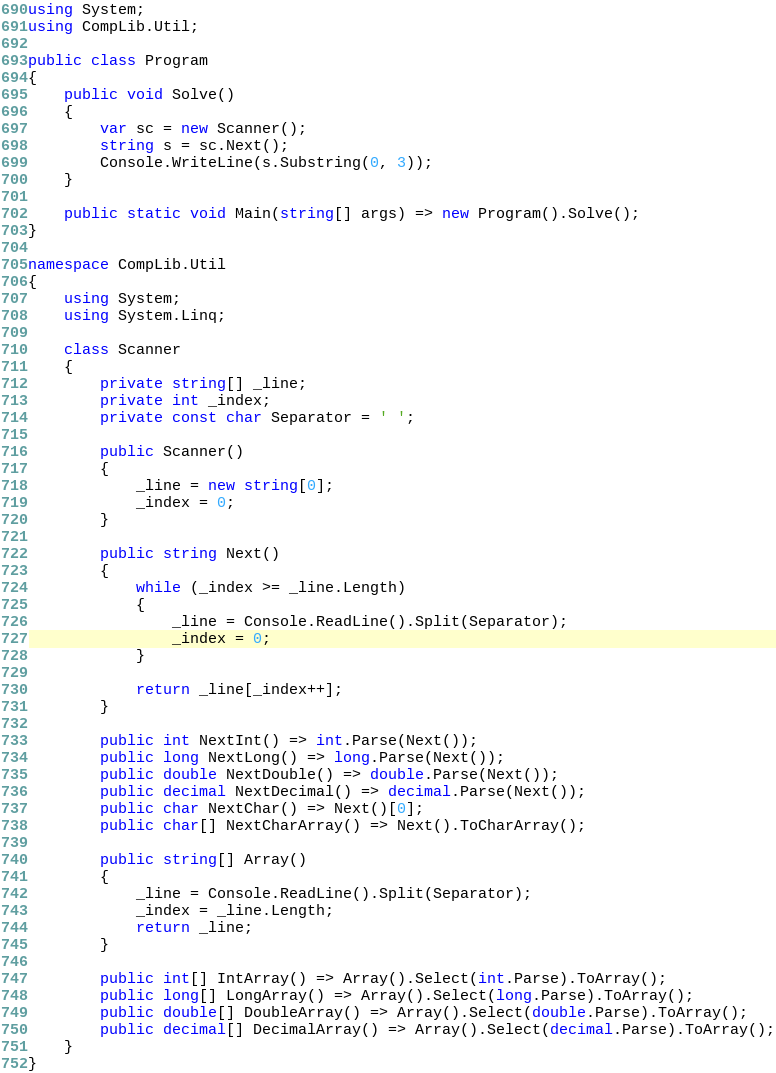<code> <loc_0><loc_0><loc_500><loc_500><_C#_>using System;
using CompLib.Util;

public class Program
{
    public void Solve()
    {
        var sc = new Scanner();
        string s = sc.Next();
        Console.WriteLine(s.Substring(0, 3));
    }

    public static void Main(string[] args) => new Program().Solve();
}

namespace CompLib.Util
{
    using System;
    using System.Linq;

    class Scanner
    {
        private string[] _line;
        private int _index;
        private const char Separator = ' ';

        public Scanner()
        {
            _line = new string[0];
            _index = 0;
        }

        public string Next()
        {
            while (_index >= _line.Length)
            {
                _line = Console.ReadLine().Split(Separator);
                _index = 0;
            }

            return _line[_index++];
        }

        public int NextInt() => int.Parse(Next());
        public long NextLong() => long.Parse(Next());
        public double NextDouble() => double.Parse(Next());
        public decimal NextDecimal() => decimal.Parse(Next());
        public char NextChar() => Next()[0];
        public char[] NextCharArray() => Next().ToCharArray();

        public string[] Array()
        {
            _line = Console.ReadLine().Split(Separator);
            _index = _line.Length;
            return _line;
        }

        public int[] IntArray() => Array().Select(int.Parse).ToArray();
        public long[] LongArray() => Array().Select(long.Parse).ToArray();
        public double[] DoubleArray() => Array().Select(double.Parse).ToArray();
        public decimal[] DecimalArray() => Array().Select(decimal.Parse).ToArray();
    }
}</code> 